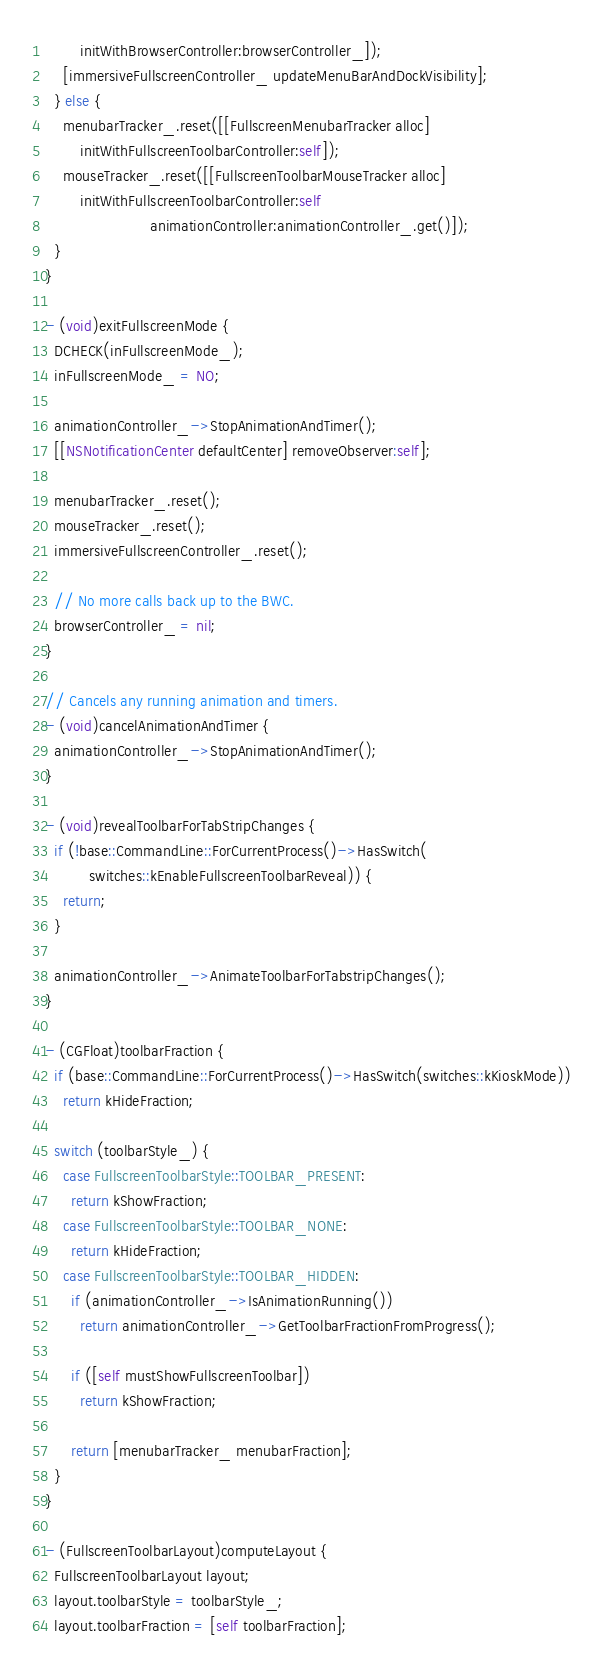Convert code to text. <code><loc_0><loc_0><loc_500><loc_500><_ObjectiveC_>        initWithBrowserController:browserController_]);
    [immersiveFullscreenController_ updateMenuBarAndDockVisibility];
  } else {
    menubarTracker_.reset([[FullscreenMenubarTracker alloc]
        initWithFullscreenToolbarController:self]);
    mouseTracker_.reset([[FullscreenToolbarMouseTracker alloc]
        initWithFullscreenToolbarController:self
                        animationController:animationController_.get()]);
  }
}

- (void)exitFullscreenMode {
  DCHECK(inFullscreenMode_);
  inFullscreenMode_ = NO;

  animationController_->StopAnimationAndTimer();
  [[NSNotificationCenter defaultCenter] removeObserver:self];

  menubarTracker_.reset();
  mouseTracker_.reset();
  immersiveFullscreenController_.reset();

  // No more calls back up to the BWC.
  browserController_ = nil;
}

// Cancels any running animation and timers.
- (void)cancelAnimationAndTimer {
  animationController_->StopAnimationAndTimer();
}

- (void)revealToolbarForTabStripChanges {
  if (!base::CommandLine::ForCurrentProcess()->HasSwitch(
          switches::kEnableFullscreenToolbarReveal)) {
    return;
  }

  animationController_->AnimateToolbarForTabstripChanges();
}

- (CGFloat)toolbarFraction {
  if (base::CommandLine::ForCurrentProcess()->HasSwitch(switches::kKioskMode))
    return kHideFraction;

  switch (toolbarStyle_) {
    case FullscreenToolbarStyle::TOOLBAR_PRESENT:
      return kShowFraction;
    case FullscreenToolbarStyle::TOOLBAR_NONE:
      return kHideFraction;
    case FullscreenToolbarStyle::TOOLBAR_HIDDEN:
      if (animationController_->IsAnimationRunning())
        return animationController_->GetToolbarFractionFromProgress();

      if ([self mustShowFullscreenToolbar])
        return kShowFraction;

      return [menubarTracker_ menubarFraction];
  }
}

- (FullscreenToolbarLayout)computeLayout {
  FullscreenToolbarLayout layout;
  layout.toolbarStyle = toolbarStyle_;
  layout.toolbarFraction = [self toolbarFraction];
</code> 